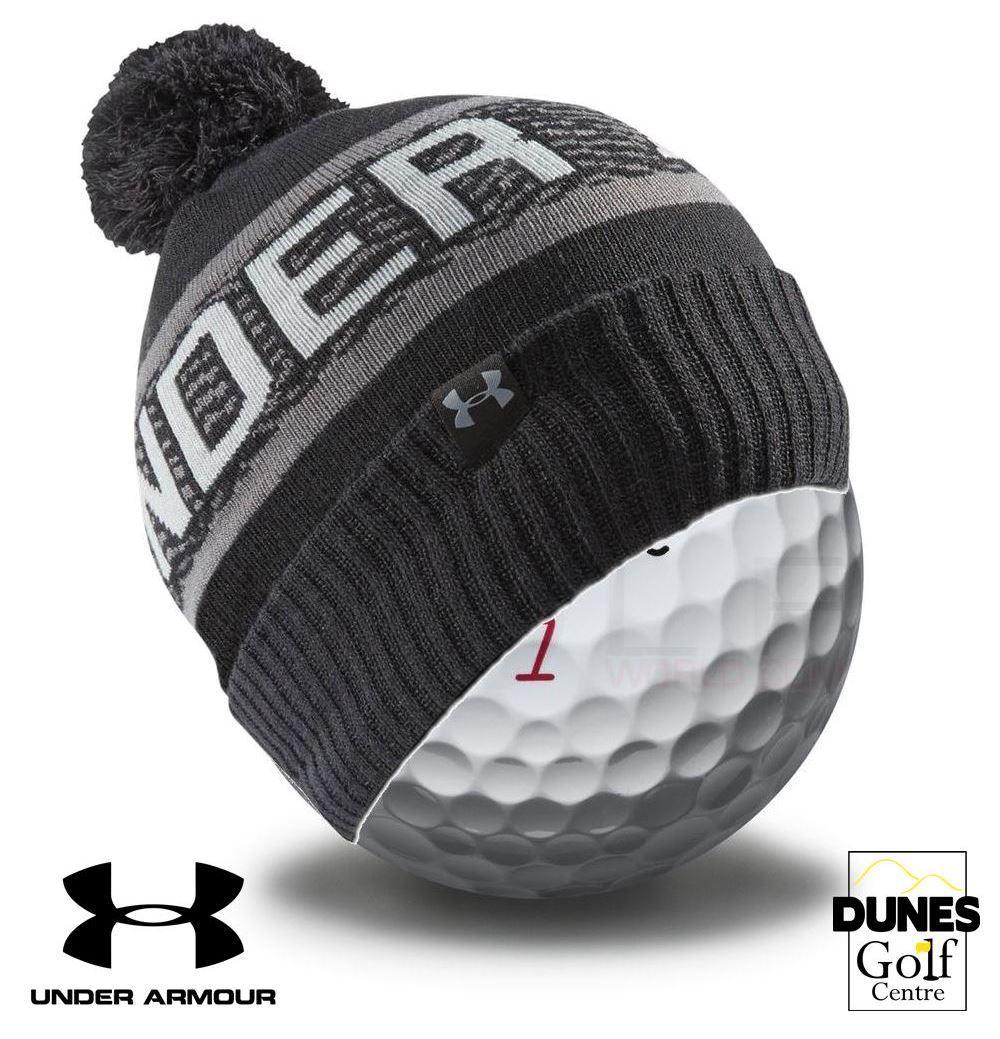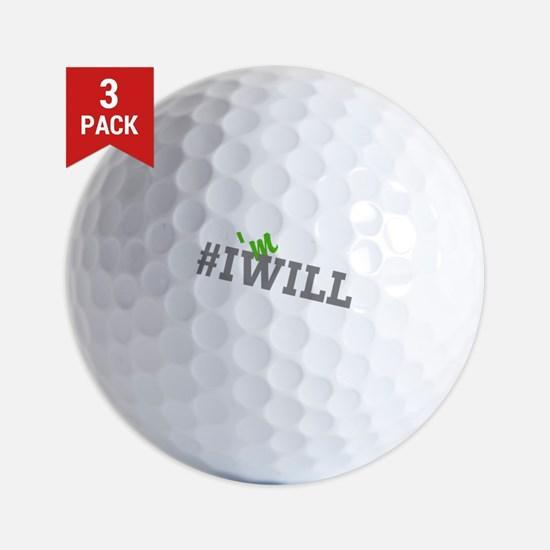The first image is the image on the left, the second image is the image on the right. For the images shown, is this caption "In at least one image there is a total of 12 golf balls." true? Answer yes or no. No. The first image is the image on the left, the second image is the image on the right. Evaluate the accuracy of this statement regarding the images: "In one of the images, 12 golf balls are lined up neatly in a 3x4 or 4x3 pattern.". Is it true? Answer yes or no. No. 